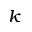<formula> <loc_0><loc_0><loc_500><loc_500>_ { k }</formula> 